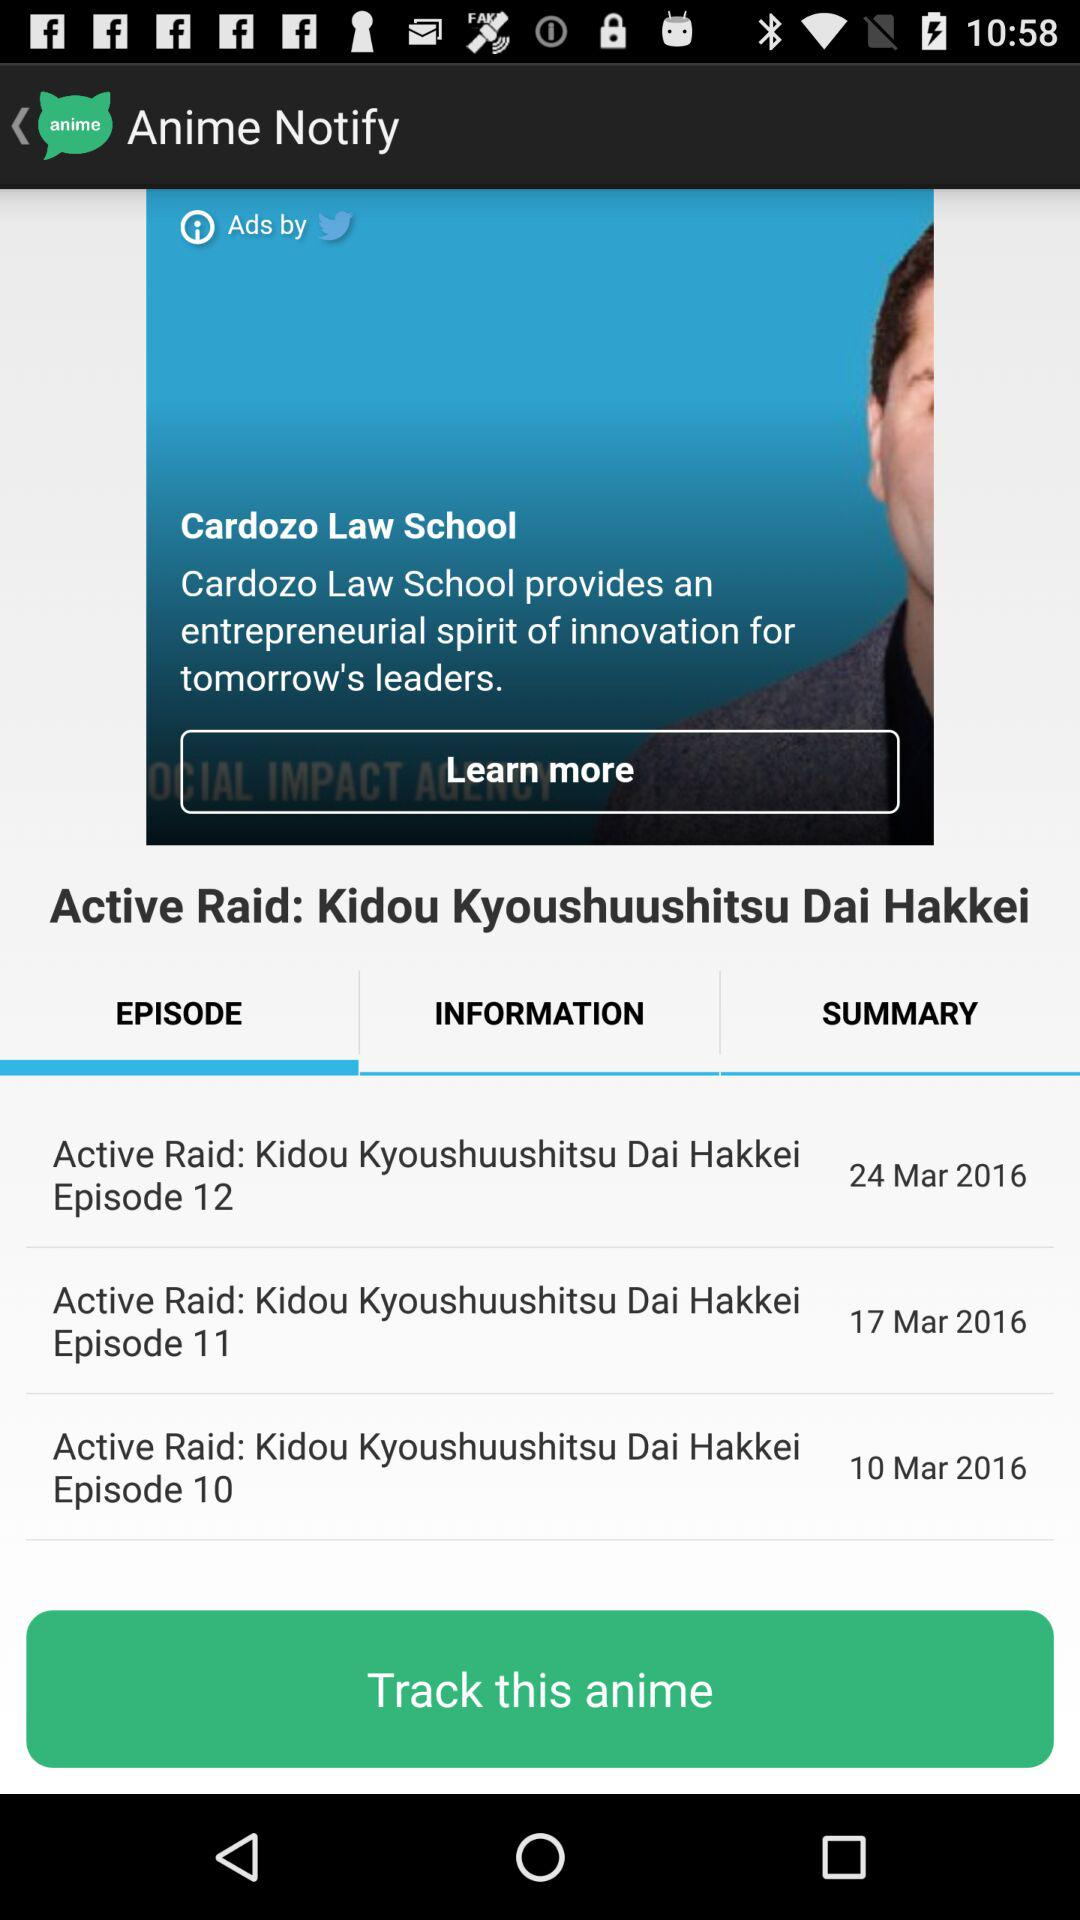Who is the author?
When the provided information is insufficient, respond with <no answer>. <no answer> 